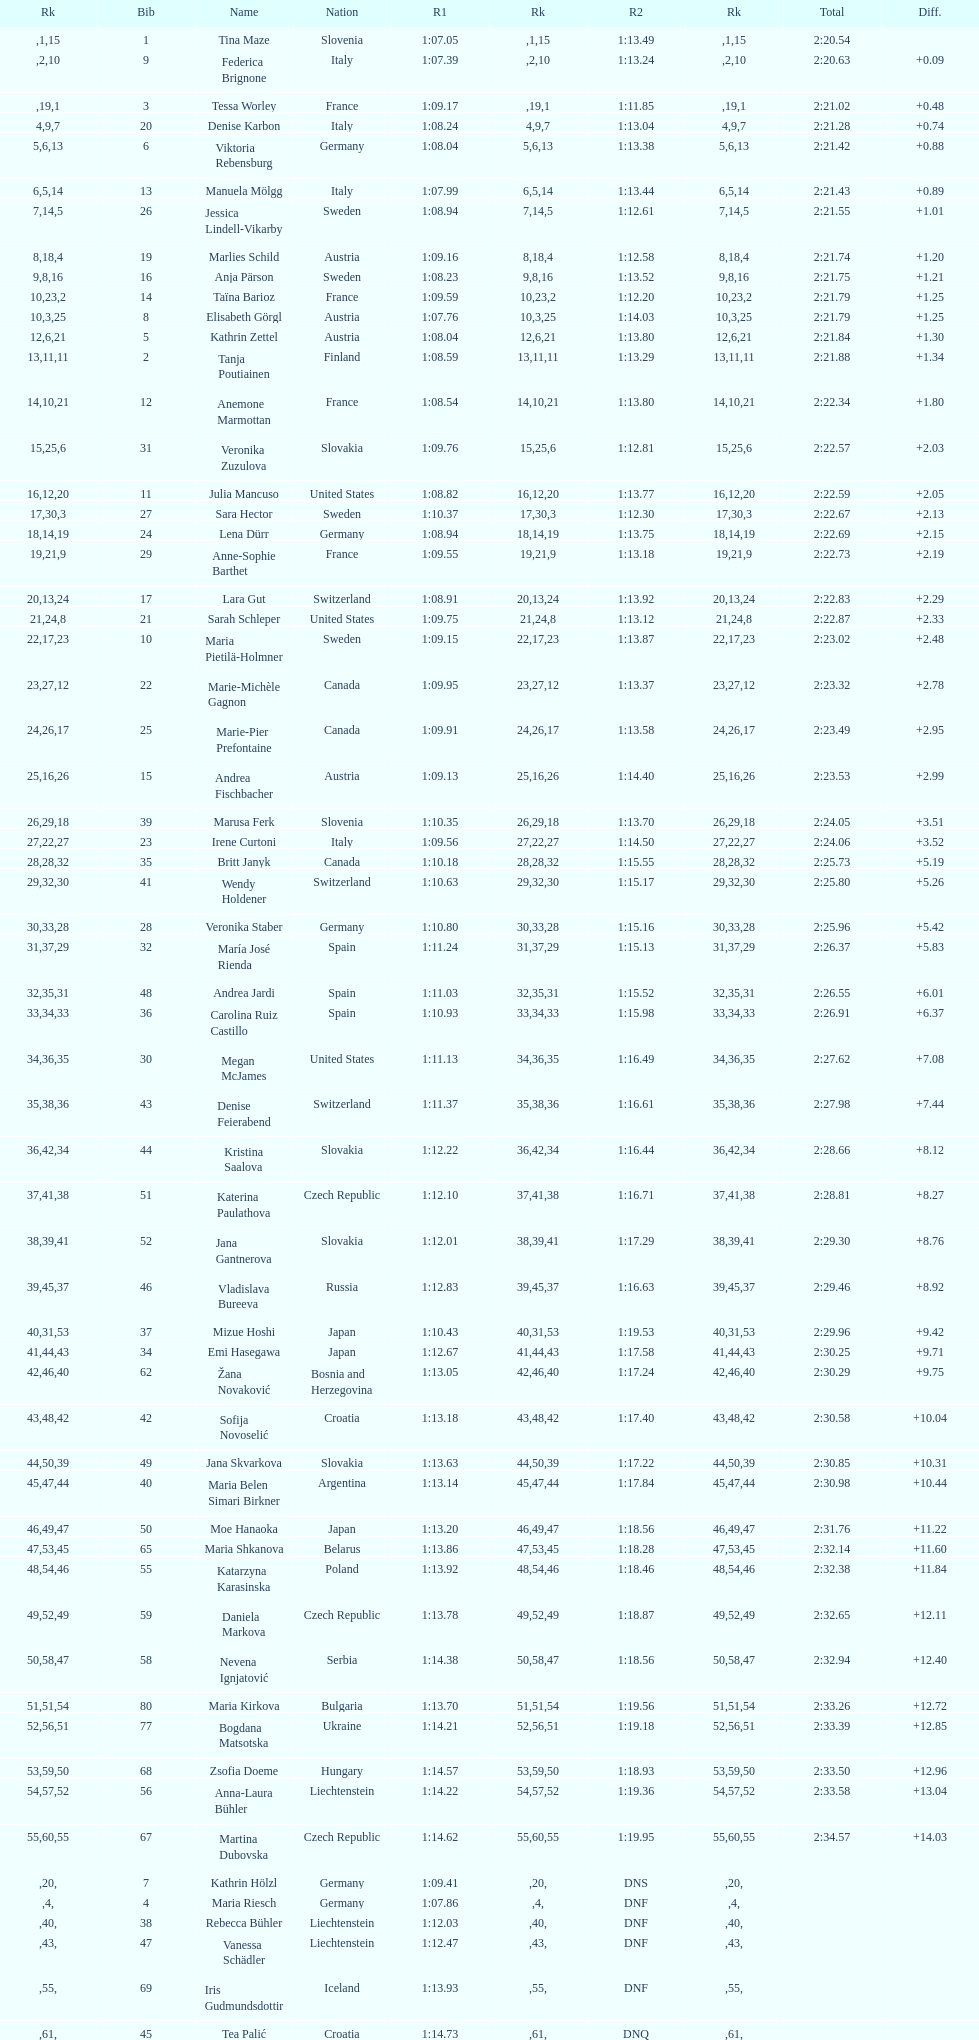Who was the final contestant to successfully complete both runs? Martina Dubovska. 